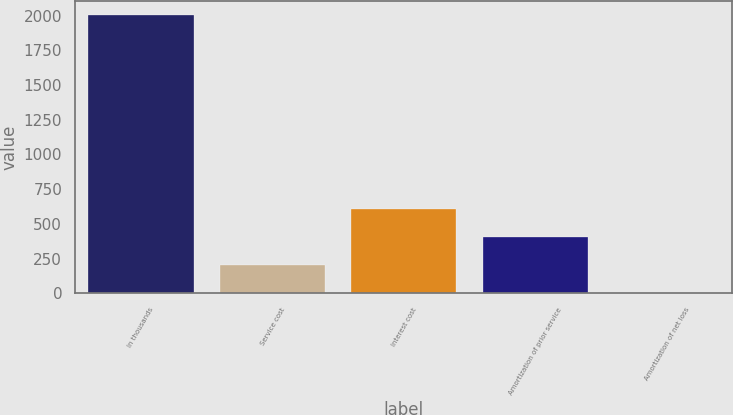Convert chart to OTSL. <chart><loc_0><loc_0><loc_500><loc_500><bar_chart><fcel>In thousands<fcel>Service cost<fcel>Interest cost<fcel>Amortization of prior service<fcel>Amortization of net loss<nl><fcel>2007<fcel>206.1<fcel>606.3<fcel>406.2<fcel>6<nl></chart> 